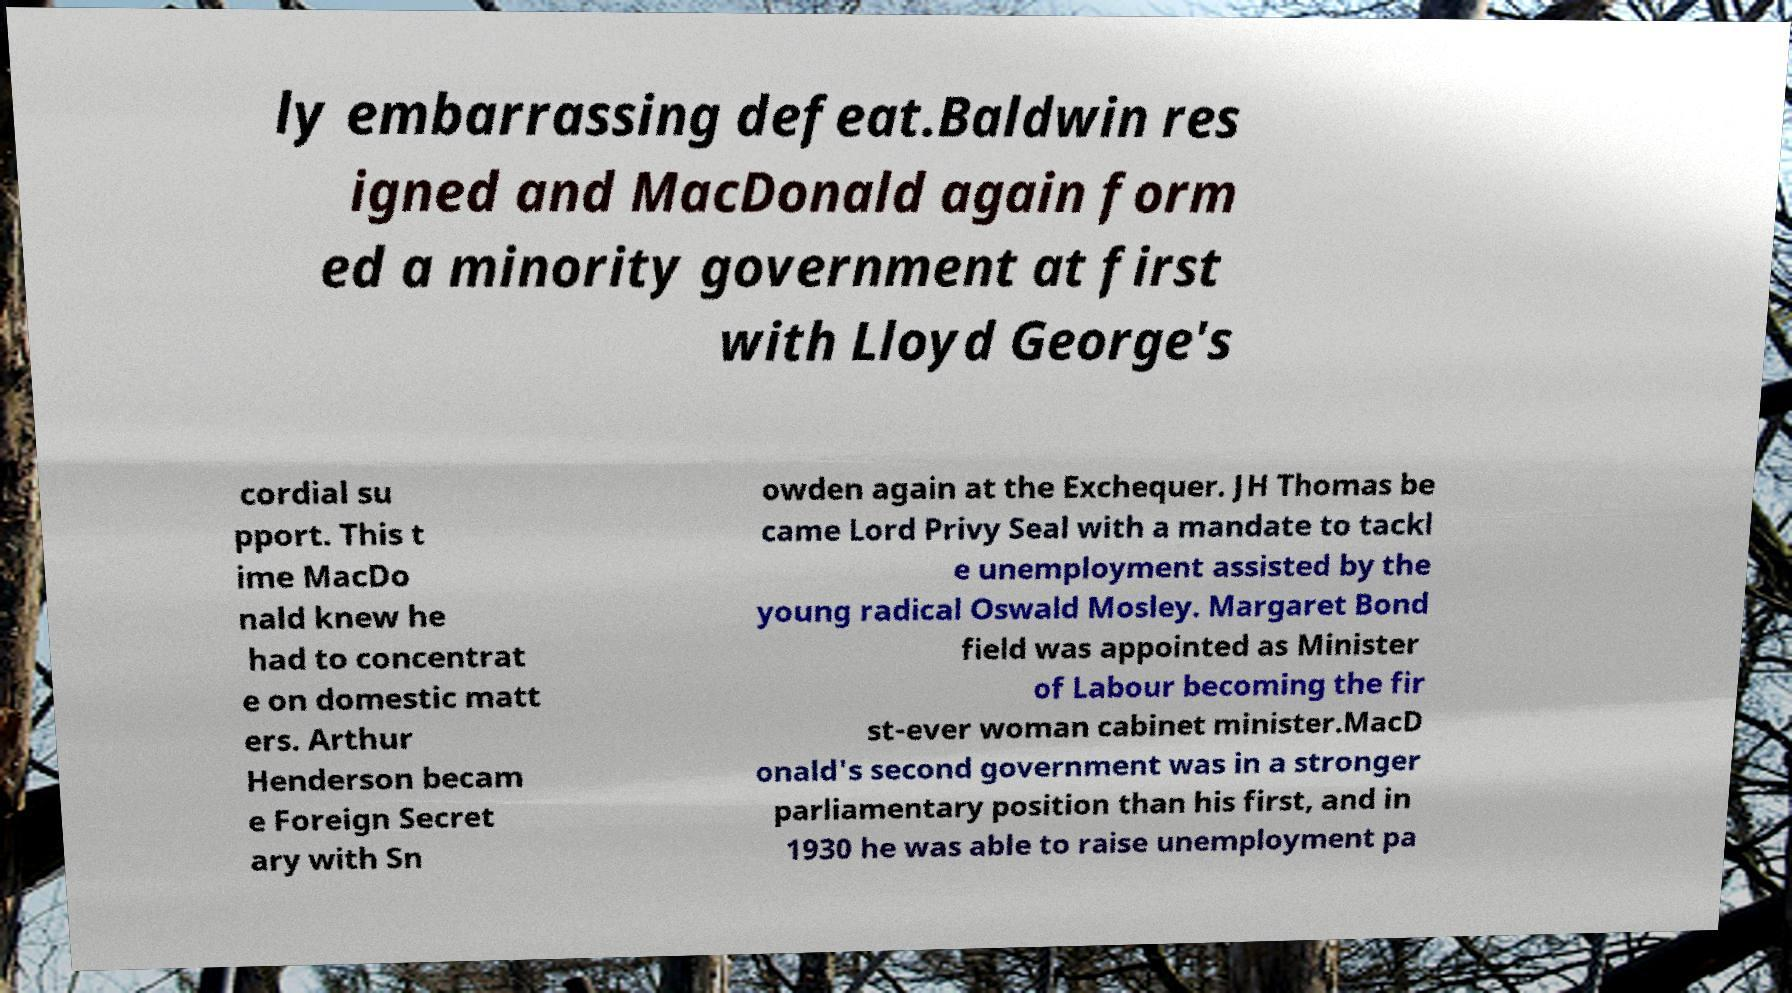For documentation purposes, I need the text within this image transcribed. Could you provide that? ly embarrassing defeat.Baldwin res igned and MacDonald again form ed a minority government at first with Lloyd George's cordial su pport. This t ime MacDo nald knew he had to concentrat e on domestic matt ers. Arthur Henderson becam e Foreign Secret ary with Sn owden again at the Exchequer. JH Thomas be came Lord Privy Seal with a mandate to tackl e unemployment assisted by the young radical Oswald Mosley. Margaret Bond field was appointed as Minister of Labour becoming the fir st-ever woman cabinet minister.MacD onald's second government was in a stronger parliamentary position than his first, and in 1930 he was able to raise unemployment pa 